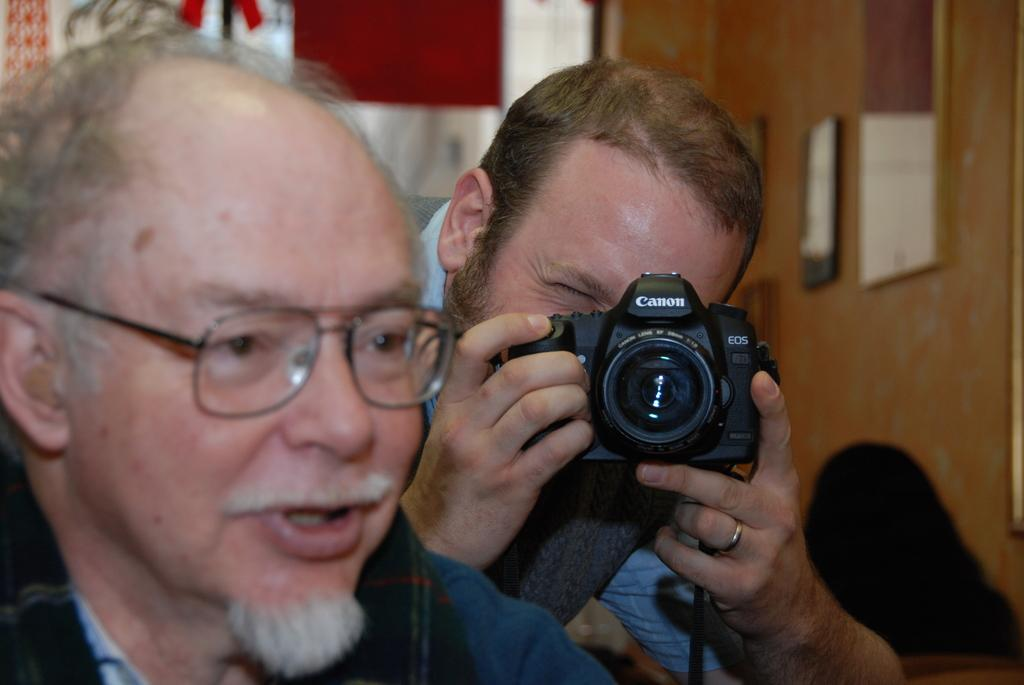What is the man in the image holding? The man is holding a camera in the image. Can you describe the positioning of the two men in the image? There is another man in front of the man with the camera. What can be observed about the man in front of the camera? The man in front of the camera is wearing spectacles. What type of drum can be seen in the image? There is no drum present in the image. How many cows are visible in the image? There are no cows visible in the image. 